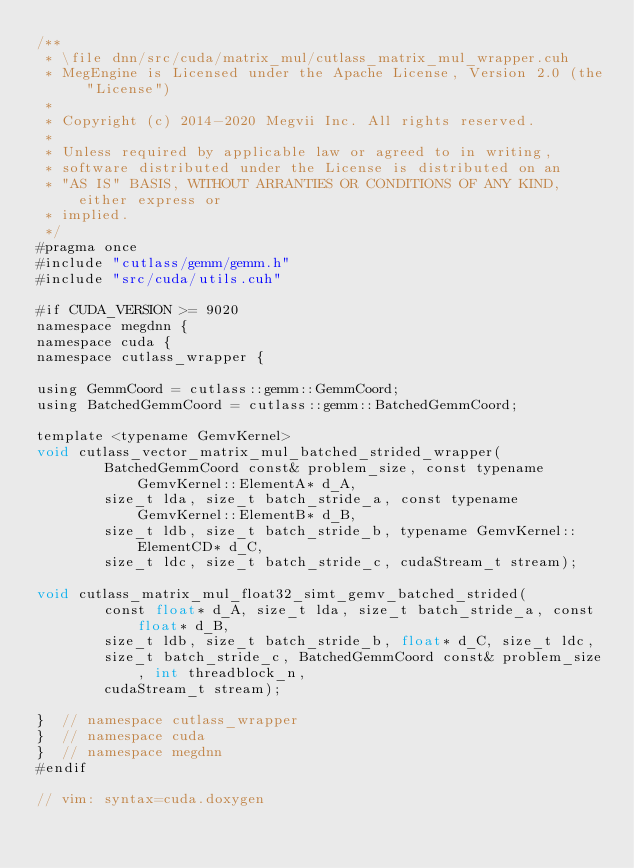<code> <loc_0><loc_0><loc_500><loc_500><_Cuda_>/**
 * \file dnn/src/cuda/matrix_mul/cutlass_matrix_mul_wrapper.cuh
 * MegEngine is Licensed under the Apache License, Version 2.0 (the "License")
 *
 * Copyright (c) 2014-2020 Megvii Inc. All rights reserved.
 *
 * Unless required by applicable law or agreed to in writing,
 * software distributed under the License is distributed on an
 * "AS IS" BASIS, WITHOUT ARRANTIES OR CONDITIONS OF ANY KIND, either express or
 * implied.
 */
#pragma once
#include "cutlass/gemm/gemm.h"
#include "src/cuda/utils.cuh"

#if CUDA_VERSION >= 9020
namespace megdnn {
namespace cuda {
namespace cutlass_wrapper {

using GemmCoord = cutlass::gemm::GemmCoord;
using BatchedGemmCoord = cutlass::gemm::BatchedGemmCoord;

template <typename GemvKernel>
void cutlass_vector_matrix_mul_batched_strided_wrapper(
        BatchedGemmCoord const& problem_size, const typename GemvKernel::ElementA* d_A,
        size_t lda, size_t batch_stride_a, const typename GemvKernel::ElementB* d_B,
        size_t ldb, size_t batch_stride_b, typename GemvKernel::ElementCD* d_C,
        size_t ldc, size_t batch_stride_c, cudaStream_t stream);

void cutlass_matrix_mul_float32_simt_gemv_batched_strided(
        const float* d_A, size_t lda, size_t batch_stride_a, const float* d_B,
        size_t ldb, size_t batch_stride_b, float* d_C, size_t ldc,
        size_t batch_stride_c, BatchedGemmCoord const& problem_size, int threadblock_n,
        cudaStream_t stream);

}  // namespace cutlass_wrapper
}  // namespace cuda
}  // namespace megdnn
#endif

// vim: syntax=cuda.doxygen
</code> 